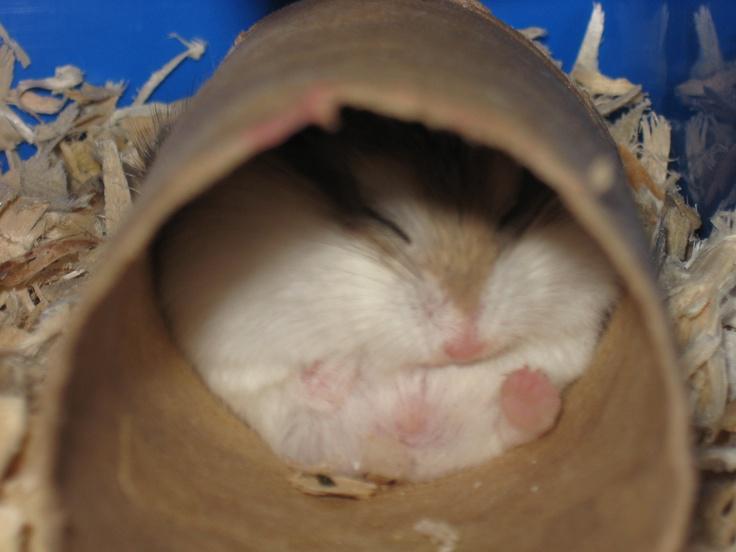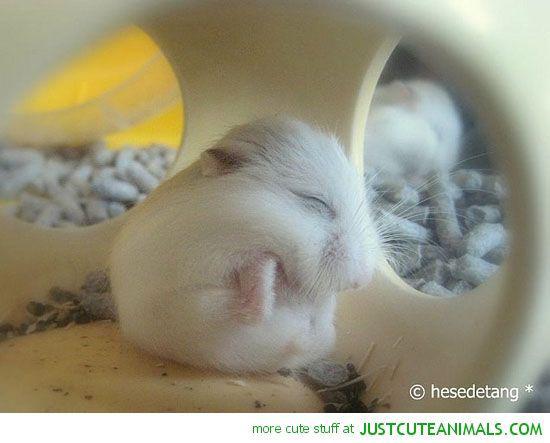The first image is the image on the left, the second image is the image on the right. For the images shown, is this caption "There is exactly one sleeping rodent in the hand of a human in the image on the right." true? Answer yes or no. No. 